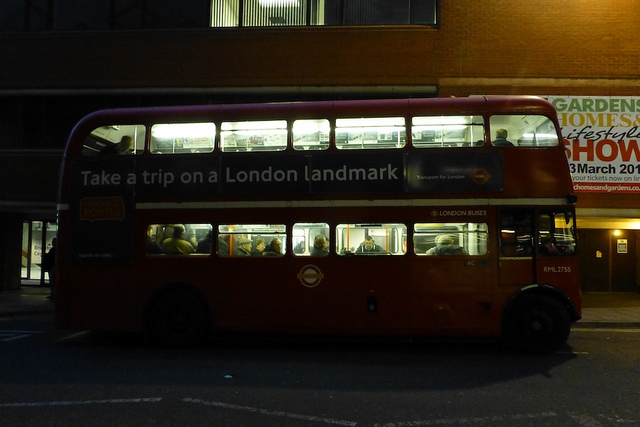What model of bus is shown in the image? The image shows a Routemaster, a classic model of double-decker bus that was a common sight in London for many years and became an iconic symbol of the city. 